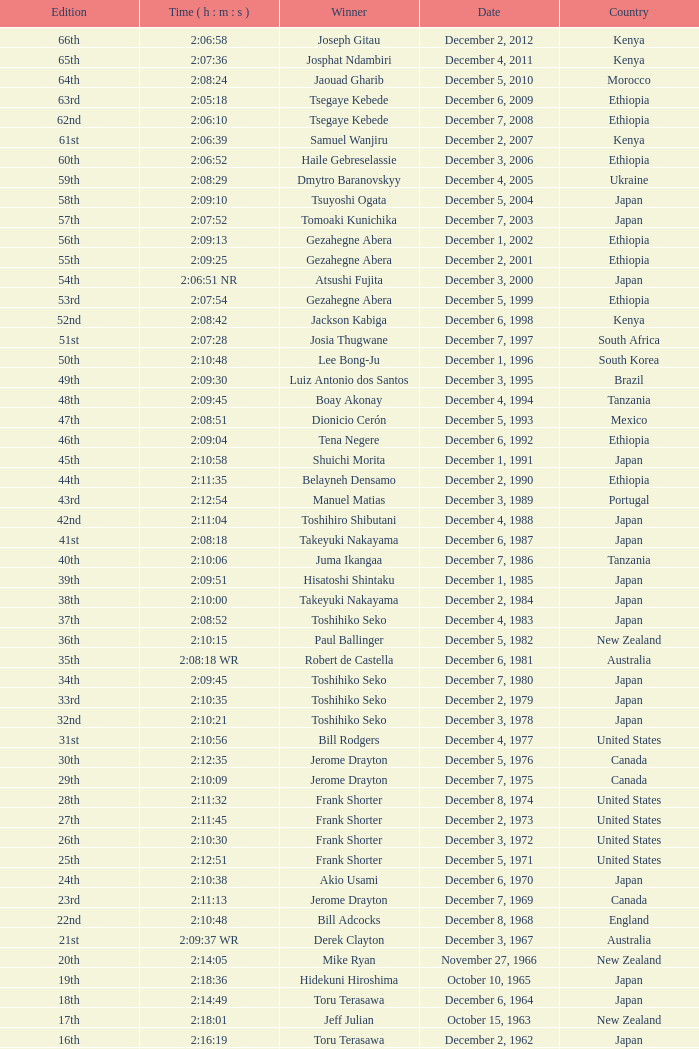What was the nationality of the winner on December 8, 1968? England. 